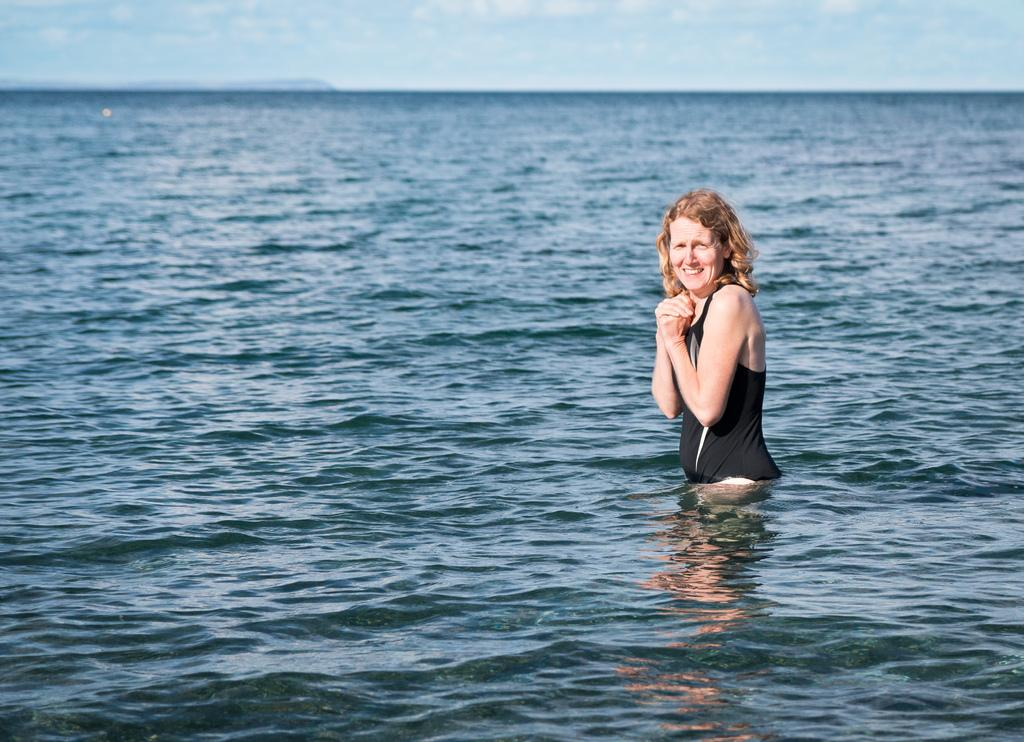Who is the main subject in the image? There is a woman in the center of the image. What is the woman doing in the image? The woman is in a river. What else can be seen in the image besides the woman? There is a river visible in the image. What is visible at the top of the image? The sky is visible at the top of the image. What type of butter is being used by the woman in the image? There is no butter present in the image. Can you see a goose swimming in the river with the woman? There is no goose visible in the image; only the woman and the river are present. 